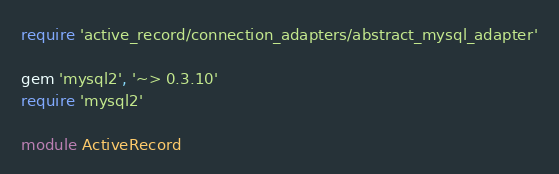Convert code to text. <code><loc_0><loc_0><loc_500><loc_500><_Ruby_>require 'active_record/connection_adapters/abstract_mysql_adapter'

gem 'mysql2', '~> 0.3.10'
require 'mysql2'

module ActiveRecord</code> 